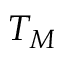<formula> <loc_0><loc_0><loc_500><loc_500>T _ { M }</formula> 